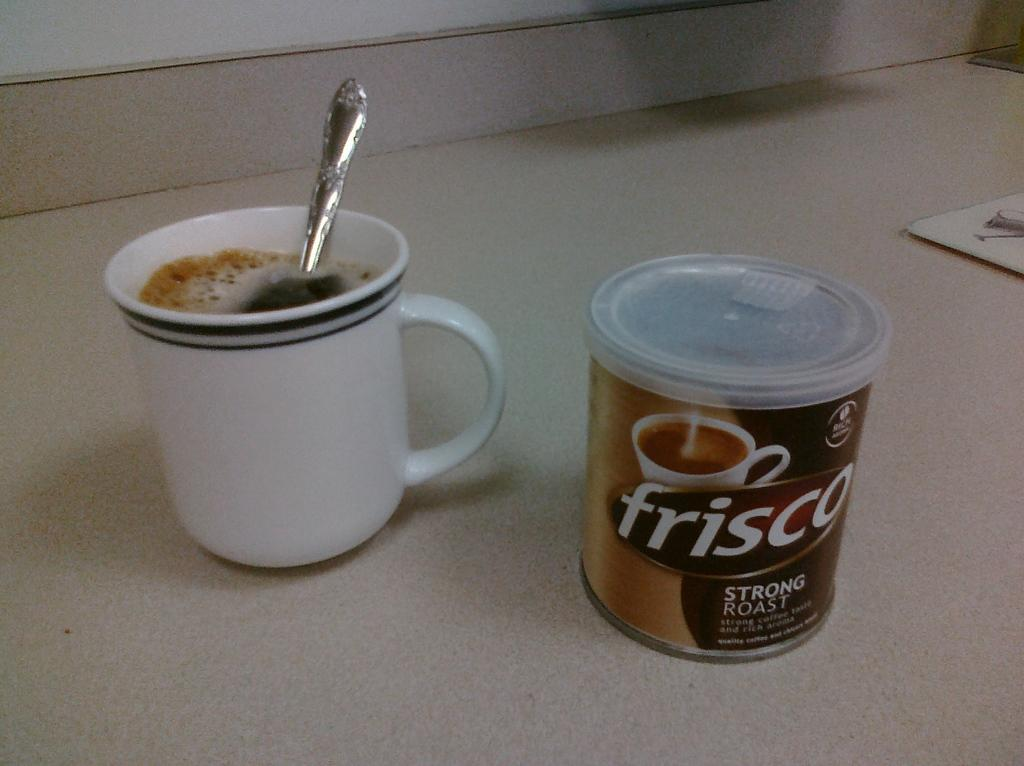What is present in the image that is used for drinking? There is a tea cup in the image that is used for drinking. What is inside the tea cup? There is a spoon in the tea cup. What else can be seen on the surface in the image? There is a coffee bottle on the surface. What type of van can be seen parked in the hall in the image? There is no van or hall present in the image; it only features a tea cup, a spoon, and a coffee bottle. 